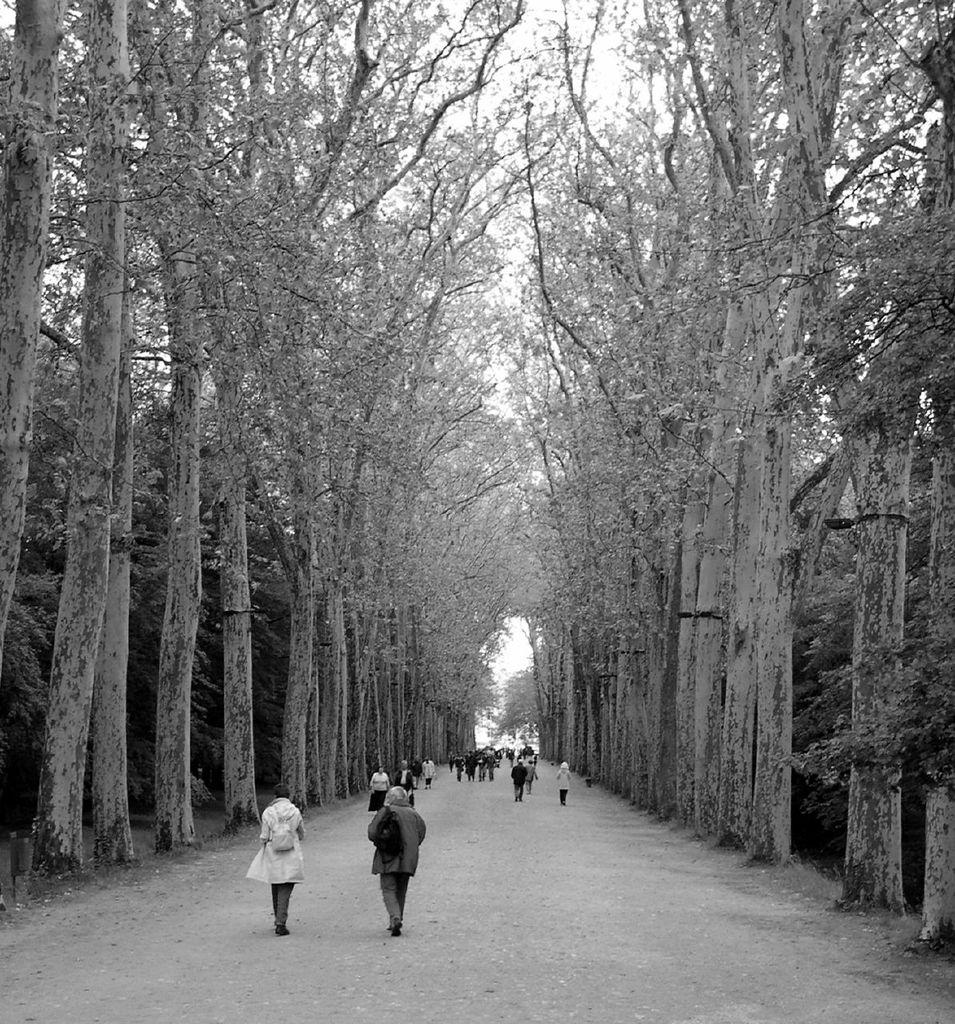What are the people in the image doing? The persons in the image are walking. Where are the people located in the image? The persons are in the center of the image. What type of natural elements can be seen in the image? There are trees in the image. Can you see a goat wearing a scarf in the image? No, there is no goat or scarf present in the image. 